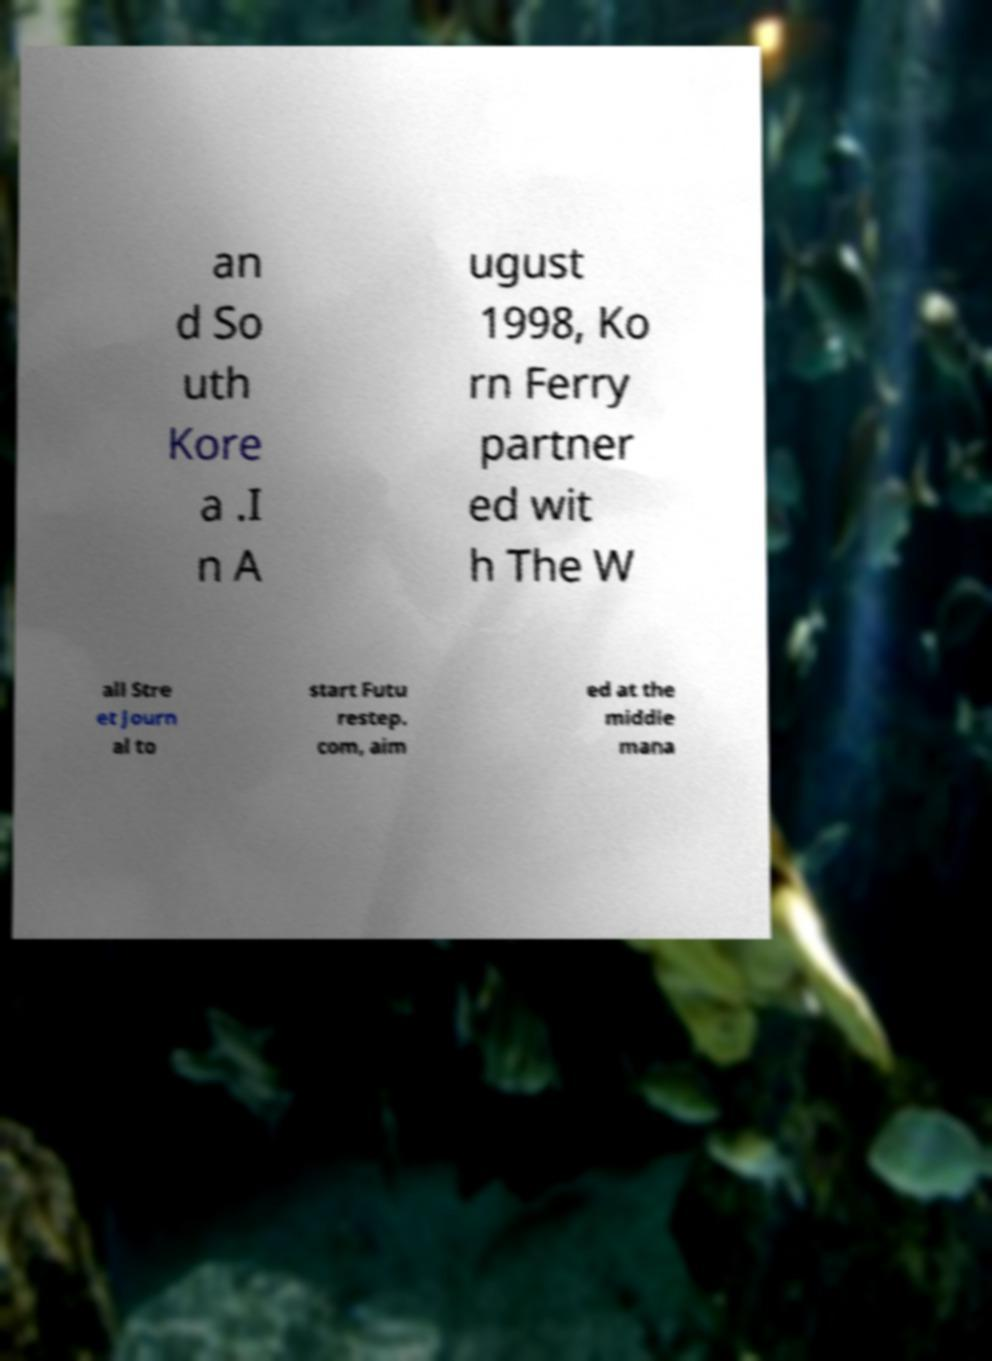Can you read and provide the text displayed in the image?This photo seems to have some interesting text. Can you extract and type it out for me? an d So uth Kore a .I n A ugust 1998, Ko rn Ferry partner ed wit h The W all Stre et Journ al to start Futu restep. com, aim ed at the middle mana 